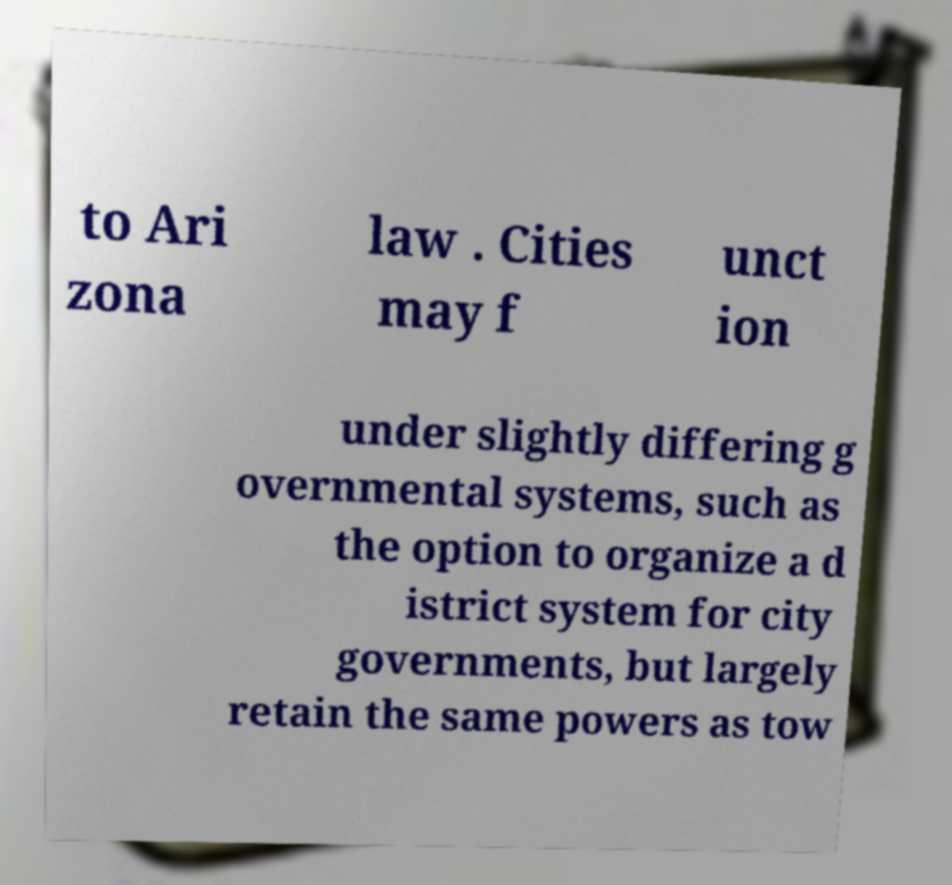Please read and relay the text visible in this image. What does it say? to Ari zona law . Cities may f unct ion under slightly differing g overnmental systems, such as the option to organize a d istrict system for city governments, but largely retain the same powers as tow 